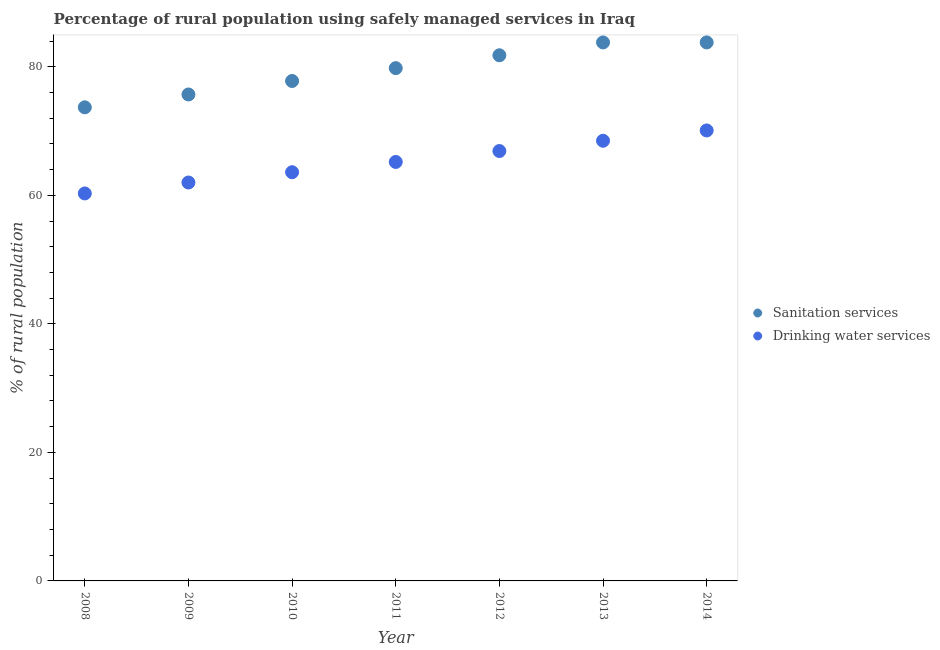Is the number of dotlines equal to the number of legend labels?
Ensure brevity in your answer.  Yes. What is the percentage of rural population who used drinking water services in 2011?
Give a very brief answer. 65.2. Across all years, what is the maximum percentage of rural population who used sanitation services?
Your answer should be very brief. 83.8. Across all years, what is the minimum percentage of rural population who used drinking water services?
Keep it short and to the point. 60.3. What is the total percentage of rural population who used drinking water services in the graph?
Your response must be concise. 456.6. What is the difference between the percentage of rural population who used sanitation services in 2009 and that in 2011?
Your answer should be compact. -4.1. What is the difference between the percentage of rural population who used drinking water services in 2010 and the percentage of rural population who used sanitation services in 2012?
Offer a very short reply. -18.2. What is the average percentage of rural population who used drinking water services per year?
Ensure brevity in your answer.  65.23. In the year 2013, what is the difference between the percentage of rural population who used drinking water services and percentage of rural population who used sanitation services?
Ensure brevity in your answer.  -15.3. What is the ratio of the percentage of rural population who used drinking water services in 2008 to that in 2012?
Give a very brief answer. 0.9. What is the difference between the highest and the second highest percentage of rural population who used drinking water services?
Keep it short and to the point. 1.6. What is the difference between the highest and the lowest percentage of rural population who used drinking water services?
Ensure brevity in your answer.  9.8. In how many years, is the percentage of rural population who used sanitation services greater than the average percentage of rural population who used sanitation services taken over all years?
Provide a succinct answer. 4. Is the percentage of rural population who used sanitation services strictly greater than the percentage of rural population who used drinking water services over the years?
Offer a terse response. Yes. How many years are there in the graph?
Make the answer very short. 7. Does the graph contain any zero values?
Give a very brief answer. No. What is the title of the graph?
Keep it short and to the point. Percentage of rural population using safely managed services in Iraq. Does "US$" appear as one of the legend labels in the graph?
Your answer should be very brief. No. What is the label or title of the X-axis?
Your response must be concise. Year. What is the label or title of the Y-axis?
Ensure brevity in your answer.  % of rural population. What is the % of rural population of Sanitation services in 2008?
Ensure brevity in your answer.  73.7. What is the % of rural population in Drinking water services in 2008?
Provide a short and direct response. 60.3. What is the % of rural population in Sanitation services in 2009?
Provide a short and direct response. 75.7. What is the % of rural population in Drinking water services in 2009?
Give a very brief answer. 62. What is the % of rural population of Sanitation services in 2010?
Offer a very short reply. 77.8. What is the % of rural population of Drinking water services in 2010?
Your answer should be very brief. 63.6. What is the % of rural population of Sanitation services in 2011?
Your response must be concise. 79.8. What is the % of rural population in Drinking water services in 2011?
Ensure brevity in your answer.  65.2. What is the % of rural population of Sanitation services in 2012?
Make the answer very short. 81.8. What is the % of rural population of Drinking water services in 2012?
Your response must be concise. 66.9. What is the % of rural population of Sanitation services in 2013?
Your response must be concise. 83.8. What is the % of rural population in Drinking water services in 2013?
Ensure brevity in your answer.  68.5. What is the % of rural population of Sanitation services in 2014?
Provide a succinct answer. 83.8. What is the % of rural population in Drinking water services in 2014?
Give a very brief answer. 70.1. Across all years, what is the maximum % of rural population of Sanitation services?
Give a very brief answer. 83.8. Across all years, what is the maximum % of rural population in Drinking water services?
Ensure brevity in your answer.  70.1. Across all years, what is the minimum % of rural population of Sanitation services?
Your response must be concise. 73.7. Across all years, what is the minimum % of rural population of Drinking water services?
Your answer should be very brief. 60.3. What is the total % of rural population of Sanitation services in the graph?
Your answer should be compact. 556.4. What is the total % of rural population of Drinking water services in the graph?
Give a very brief answer. 456.6. What is the difference between the % of rural population in Sanitation services in 2008 and that in 2009?
Your response must be concise. -2. What is the difference between the % of rural population in Drinking water services in 2008 and that in 2009?
Offer a very short reply. -1.7. What is the difference between the % of rural population of Sanitation services in 2008 and that in 2010?
Your answer should be compact. -4.1. What is the difference between the % of rural population of Drinking water services in 2008 and that in 2010?
Offer a terse response. -3.3. What is the difference between the % of rural population in Sanitation services in 2008 and that in 2013?
Your response must be concise. -10.1. What is the difference between the % of rural population of Drinking water services in 2008 and that in 2014?
Your answer should be compact. -9.8. What is the difference between the % of rural population in Drinking water services in 2009 and that in 2011?
Make the answer very short. -3.2. What is the difference between the % of rural population of Drinking water services in 2009 and that in 2012?
Offer a very short reply. -4.9. What is the difference between the % of rural population of Drinking water services in 2009 and that in 2013?
Offer a very short reply. -6.5. What is the difference between the % of rural population of Sanitation services in 2009 and that in 2014?
Provide a succinct answer. -8.1. What is the difference between the % of rural population of Drinking water services in 2009 and that in 2014?
Make the answer very short. -8.1. What is the difference between the % of rural population of Drinking water services in 2010 and that in 2011?
Your answer should be very brief. -1.6. What is the difference between the % of rural population in Sanitation services in 2010 and that in 2012?
Your answer should be very brief. -4. What is the difference between the % of rural population in Drinking water services in 2010 and that in 2012?
Offer a terse response. -3.3. What is the difference between the % of rural population of Drinking water services in 2010 and that in 2013?
Your answer should be very brief. -4.9. What is the difference between the % of rural population of Drinking water services in 2010 and that in 2014?
Ensure brevity in your answer.  -6.5. What is the difference between the % of rural population of Sanitation services in 2011 and that in 2013?
Give a very brief answer. -4. What is the difference between the % of rural population of Drinking water services in 2011 and that in 2013?
Your answer should be compact. -3.3. What is the difference between the % of rural population in Sanitation services in 2011 and that in 2014?
Offer a very short reply. -4. What is the difference between the % of rural population of Drinking water services in 2011 and that in 2014?
Provide a succinct answer. -4.9. What is the difference between the % of rural population in Drinking water services in 2012 and that in 2014?
Offer a very short reply. -3.2. What is the difference between the % of rural population of Sanitation services in 2013 and that in 2014?
Your response must be concise. 0. What is the difference between the % of rural population in Sanitation services in 2008 and the % of rural population in Drinking water services in 2009?
Give a very brief answer. 11.7. What is the difference between the % of rural population of Sanitation services in 2008 and the % of rural population of Drinking water services in 2011?
Provide a short and direct response. 8.5. What is the difference between the % of rural population in Sanitation services in 2009 and the % of rural population in Drinking water services in 2010?
Give a very brief answer. 12.1. What is the difference between the % of rural population of Sanitation services in 2009 and the % of rural population of Drinking water services in 2013?
Make the answer very short. 7.2. What is the difference between the % of rural population in Sanitation services in 2010 and the % of rural population in Drinking water services in 2012?
Your answer should be very brief. 10.9. What is the difference between the % of rural population of Sanitation services in 2010 and the % of rural population of Drinking water services in 2013?
Ensure brevity in your answer.  9.3. What is the difference between the % of rural population of Sanitation services in 2010 and the % of rural population of Drinking water services in 2014?
Your response must be concise. 7.7. What is the difference between the % of rural population in Sanitation services in 2011 and the % of rural population in Drinking water services in 2013?
Give a very brief answer. 11.3. What is the difference between the % of rural population of Sanitation services in 2011 and the % of rural population of Drinking water services in 2014?
Make the answer very short. 9.7. What is the difference between the % of rural population of Sanitation services in 2012 and the % of rural population of Drinking water services in 2013?
Provide a succinct answer. 13.3. What is the difference between the % of rural population of Sanitation services in 2013 and the % of rural population of Drinking water services in 2014?
Offer a very short reply. 13.7. What is the average % of rural population of Sanitation services per year?
Offer a terse response. 79.49. What is the average % of rural population of Drinking water services per year?
Your response must be concise. 65.23. In the year 2010, what is the difference between the % of rural population in Sanitation services and % of rural population in Drinking water services?
Ensure brevity in your answer.  14.2. In the year 2012, what is the difference between the % of rural population of Sanitation services and % of rural population of Drinking water services?
Your response must be concise. 14.9. What is the ratio of the % of rural population of Sanitation services in 2008 to that in 2009?
Your answer should be compact. 0.97. What is the ratio of the % of rural population in Drinking water services in 2008 to that in 2009?
Your answer should be compact. 0.97. What is the ratio of the % of rural population of Sanitation services in 2008 to that in 2010?
Your response must be concise. 0.95. What is the ratio of the % of rural population in Drinking water services in 2008 to that in 2010?
Ensure brevity in your answer.  0.95. What is the ratio of the % of rural population in Sanitation services in 2008 to that in 2011?
Make the answer very short. 0.92. What is the ratio of the % of rural population of Drinking water services in 2008 to that in 2011?
Provide a short and direct response. 0.92. What is the ratio of the % of rural population of Sanitation services in 2008 to that in 2012?
Your answer should be very brief. 0.9. What is the ratio of the % of rural population in Drinking water services in 2008 to that in 2012?
Provide a succinct answer. 0.9. What is the ratio of the % of rural population in Sanitation services in 2008 to that in 2013?
Provide a short and direct response. 0.88. What is the ratio of the % of rural population of Drinking water services in 2008 to that in 2013?
Make the answer very short. 0.88. What is the ratio of the % of rural population in Sanitation services in 2008 to that in 2014?
Provide a succinct answer. 0.88. What is the ratio of the % of rural population in Drinking water services in 2008 to that in 2014?
Make the answer very short. 0.86. What is the ratio of the % of rural population in Drinking water services in 2009 to that in 2010?
Give a very brief answer. 0.97. What is the ratio of the % of rural population of Sanitation services in 2009 to that in 2011?
Your answer should be compact. 0.95. What is the ratio of the % of rural population in Drinking water services in 2009 to that in 2011?
Give a very brief answer. 0.95. What is the ratio of the % of rural population in Sanitation services in 2009 to that in 2012?
Give a very brief answer. 0.93. What is the ratio of the % of rural population in Drinking water services in 2009 to that in 2012?
Your response must be concise. 0.93. What is the ratio of the % of rural population of Sanitation services in 2009 to that in 2013?
Ensure brevity in your answer.  0.9. What is the ratio of the % of rural population in Drinking water services in 2009 to that in 2013?
Your answer should be compact. 0.91. What is the ratio of the % of rural population in Sanitation services in 2009 to that in 2014?
Give a very brief answer. 0.9. What is the ratio of the % of rural population of Drinking water services in 2009 to that in 2014?
Provide a succinct answer. 0.88. What is the ratio of the % of rural population of Sanitation services in 2010 to that in 2011?
Offer a very short reply. 0.97. What is the ratio of the % of rural population of Drinking water services in 2010 to that in 2011?
Give a very brief answer. 0.98. What is the ratio of the % of rural population of Sanitation services in 2010 to that in 2012?
Your answer should be very brief. 0.95. What is the ratio of the % of rural population in Drinking water services in 2010 to that in 2012?
Keep it short and to the point. 0.95. What is the ratio of the % of rural population in Sanitation services in 2010 to that in 2013?
Your answer should be compact. 0.93. What is the ratio of the % of rural population of Drinking water services in 2010 to that in 2013?
Your answer should be compact. 0.93. What is the ratio of the % of rural population in Sanitation services in 2010 to that in 2014?
Offer a terse response. 0.93. What is the ratio of the % of rural population in Drinking water services in 2010 to that in 2014?
Offer a terse response. 0.91. What is the ratio of the % of rural population of Sanitation services in 2011 to that in 2012?
Offer a very short reply. 0.98. What is the ratio of the % of rural population of Drinking water services in 2011 to that in 2012?
Keep it short and to the point. 0.97. What is the ratio of the % of rural population of Sanitation services in 2011 to that in 2013?
Give a very brief answer. 0.95. What is the ratio of the % of rural population in Drinking water services in 2011 to that in 2013?
Provide a succinct answer. 0.95. What is the ratio of the % of rural population in Sanitation services in 2011 to that in 2014?
Provide a succinct answer. 0.95. What is the ratio of the % of rural population of Drinking water services in 2011 to that in 2014?
Your response must be concise. 0.93. What is the ratio of the % of rural population in Sanitation services in 2012 to that in 2013?
Give a very brief answer. 0.98. What is the ratio of the % of rural population of Drinking water services in 2012 to that in 2013?
Offer a terse response. 0.98. What is the ratio of the % of rural population of Sanitation services in 2012 to that in 2014?
Your response must be concise. 0.98. What is the ratio of the % of rural population in Drinking water services in 2012 to that in 2014?
Make the answer very short. 0.95. What is the ratio of the % of rural population in Sanitation services in 2013 to that in 2014?
Ensure brevity in your answer.  1. What is the ratio of the % of rural population of Drinking water services in 2013 to that in 2014?
Your answer should be very brief. 0.98. What is the difference between the highest and the second highest % of rural population in Drinking water services?
Your response must be concise. 1.6. What is the difference between the highest and the lowest % of rural population of Sanitation services?
Offer a very short reply. 10.1. What is the difference between the highest and the lowest % of rural population of Drinking water services?
Provide a succinct answer. 9.8. 